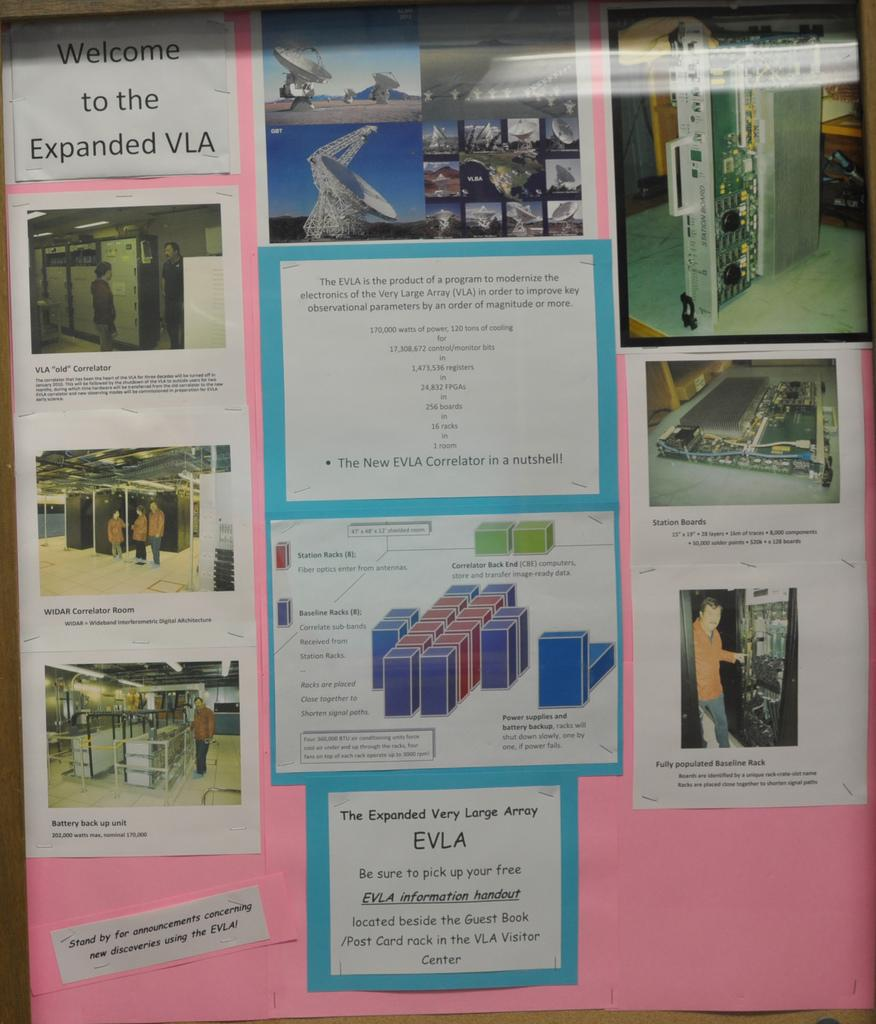Provide a one-sentence caption for the provided image. Display with pink background that says "Welcome to the Expanded VLA". 